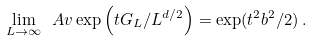<formula> <loc_0><loc_0><loc_500><loc_500>\lim _ { L \to \infty } \ A v \exp \left ( t G _ { L } / L ^ { d / 2 } \right ) = \exp ( t ^ { 2 } b ^ { 2 } / 2 ) \, .</formula> 